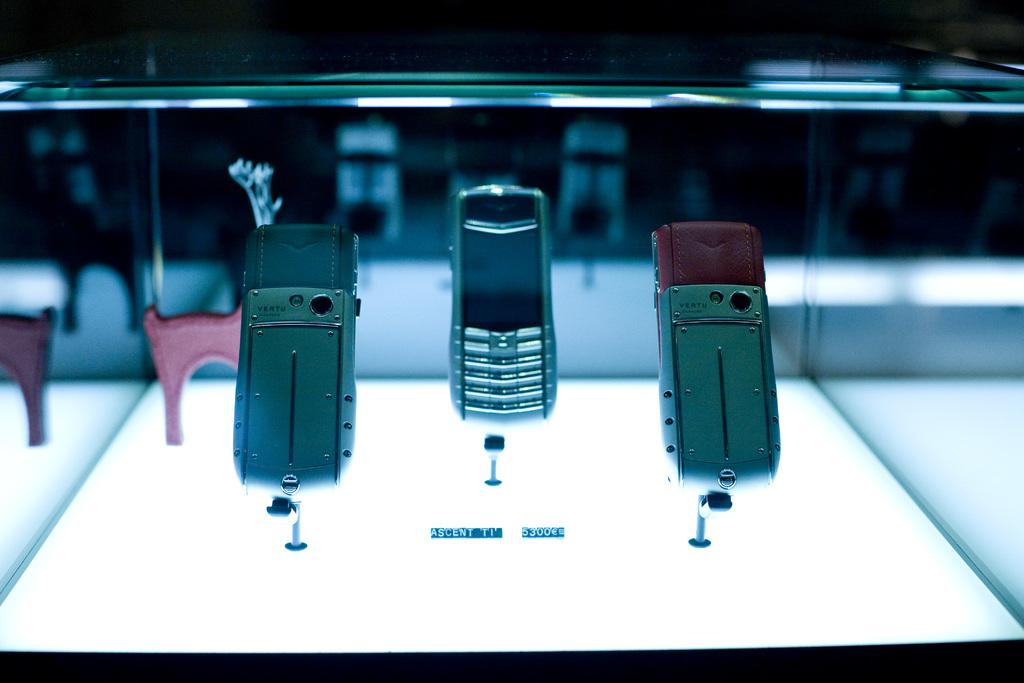<image>
Provide a brief description of the given image. a phone among others with the word vertu on it 